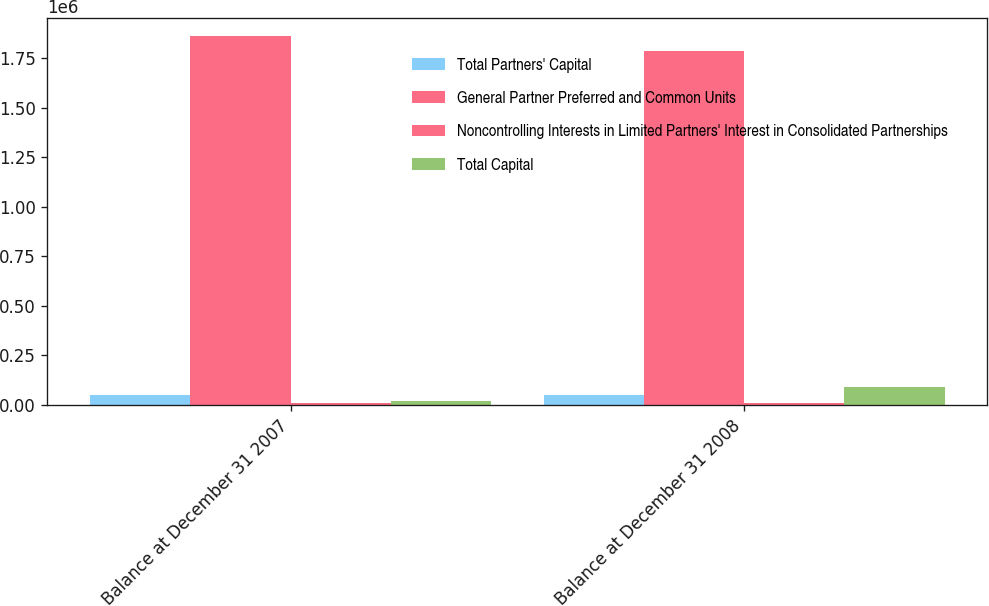<chart> <loc_0><loc_0><loc_500><loc_500><stacked_bar_chart><ecel><fcel>Balance at December 31 2007<fcel>Balance at December 31 2008<nl><fcel>Total Partners' Capital<fcel>49158<fcel>49158<nl><fcel>General Partner Preferred and Common Units<fcel>1.86168e+06<fcel>1.78755e+06<nl><fcel>Noncontrolling Interests in Limited Partners' Interest in Consolidated Partnerships<fcel>9919<fcel>8283<nl><fcel>Total Capital<fcel>18622<fcel>90689<nl></chart> 